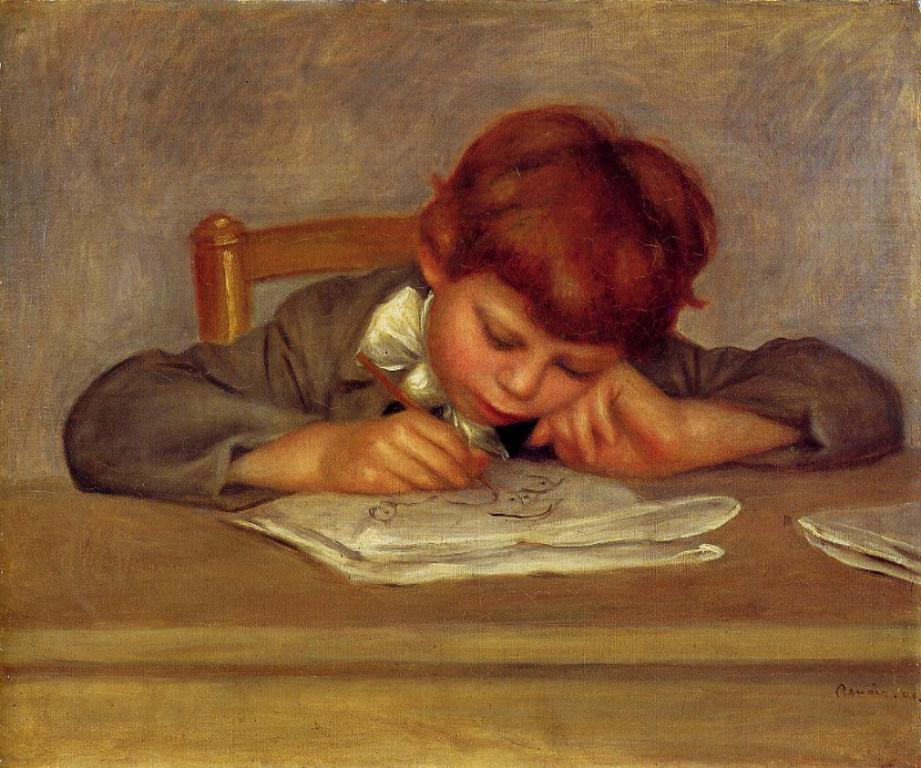Who is the main subject in the image? There is a boy in the image. What is the boy doing in the image? The boy is sitting on a chair and writing on a book with a pen. Where is the boy sitting? The boy is sitting on a chair at a table. What else can be seen on the table? There are books on the table. What is visible in the background of the image? There is a wall in the image. What type of pancake is the boy eating during the meeting with the manager? There is no meeting with a manager or any pancake present in the image. 